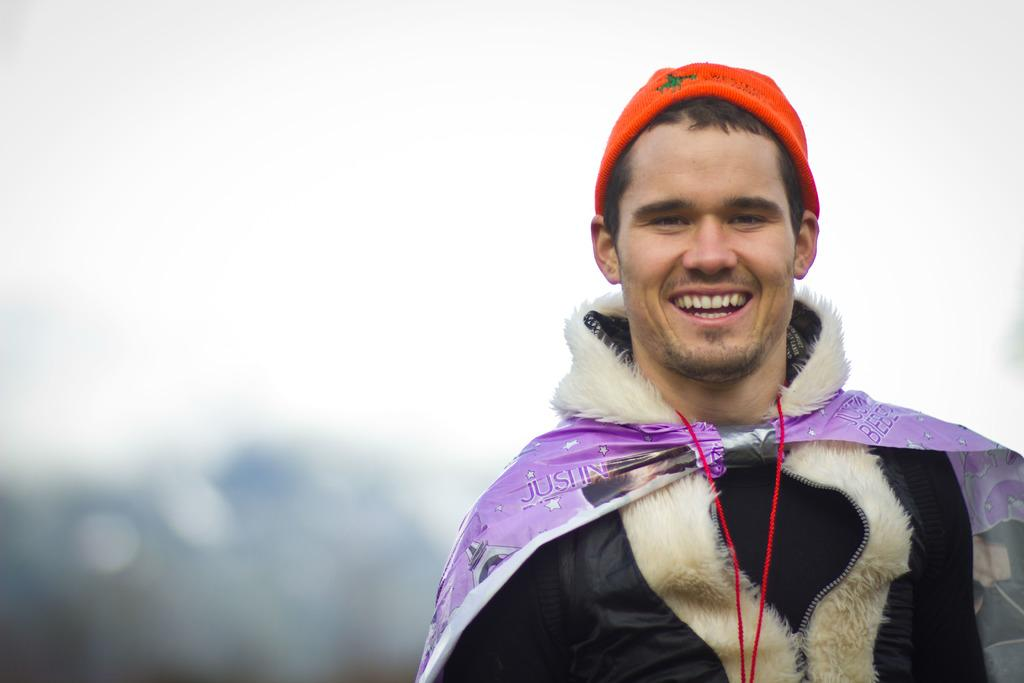What can be seen in the image? There are persons standing in the image. What are the persons wearing on their heads? The persons are wearing caps. What is visible in the background of the image? There is sky visible in the background of the image. Are there any ghosts visible in the image? No, there are no ghosts present in the image. What type of card can be seen being played by the persons in the image? There is no card visible in the image; the persons are wearing caps. 